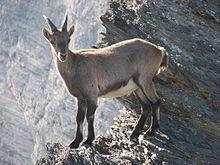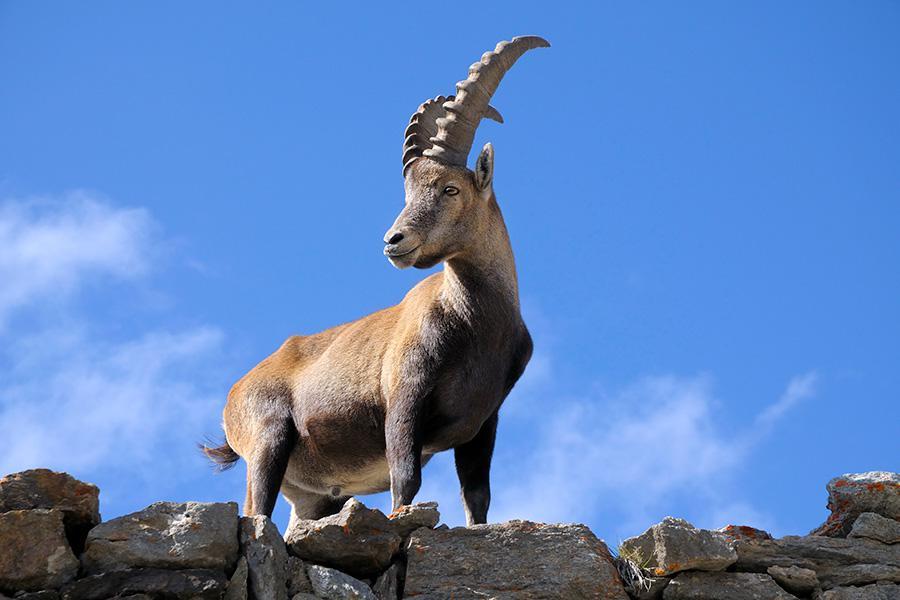The first image is the image on the left, the second image is the image on the right. Examine the images to the left and right. Is the description "One image contains one hooved animal with short horns, which is standing on some platform with its body turned leftward." accurate? Answer yes or no. Yes. The first image is the image on the left, the second image is the image on the right. Analyze the images presented: Is the assertion "There are more rams in the image on the right than in the image on the left." valid? Answer yes or no. No. 